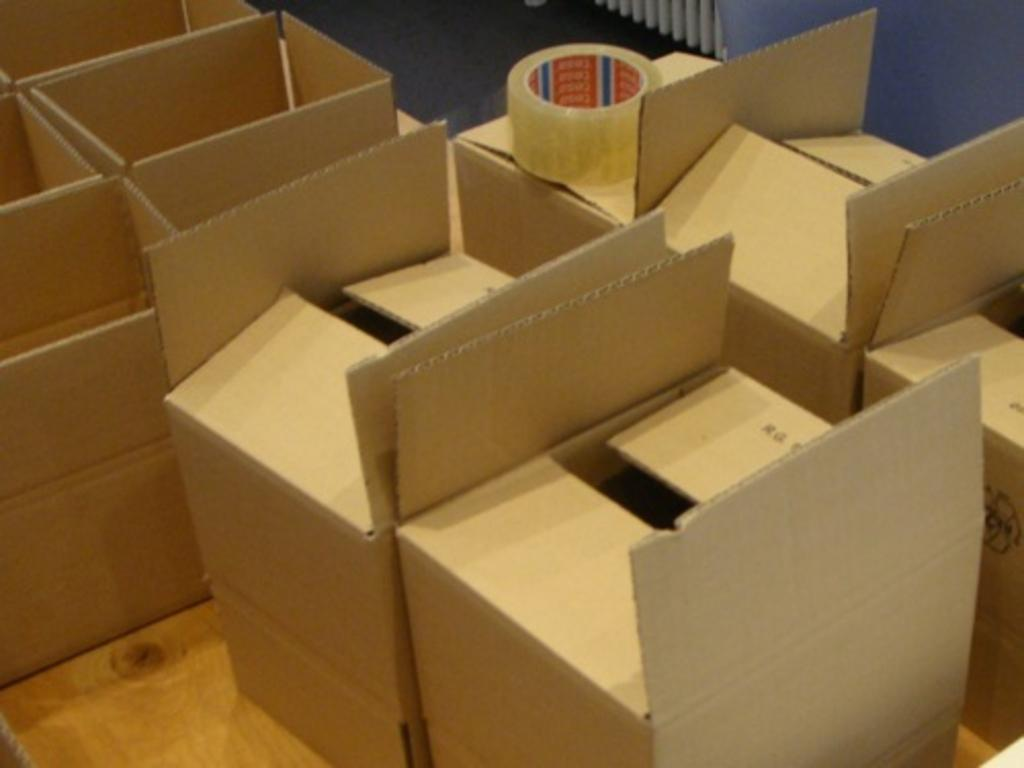What objects are present in the image? There are boxes in the image. Where are the boxes located? The boxes are kept on the floor. What is placed on top of at least one box? There is a plaster on top of at least one box. Can you see any bicycles or the ocean in the image? No, there are no bicycles or the ocean present in the image. Is the person in the image dancing? No, the person is sitting on a chair and holding a book, not dancing. 